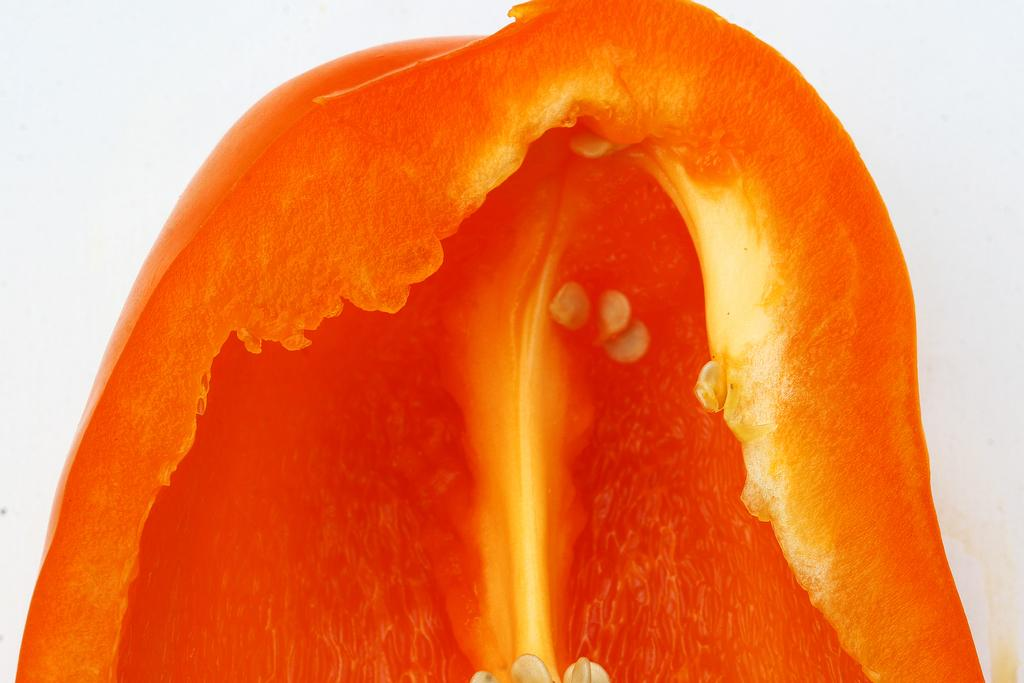What type of vegetable is present in the image? There is a piece of red bell pepper in the image. What color is the background of the image? The background of the image is white. How many cacti are visible in the image? There are no cacti present in the image; it only features a piece of red bell pepper against a white background. 